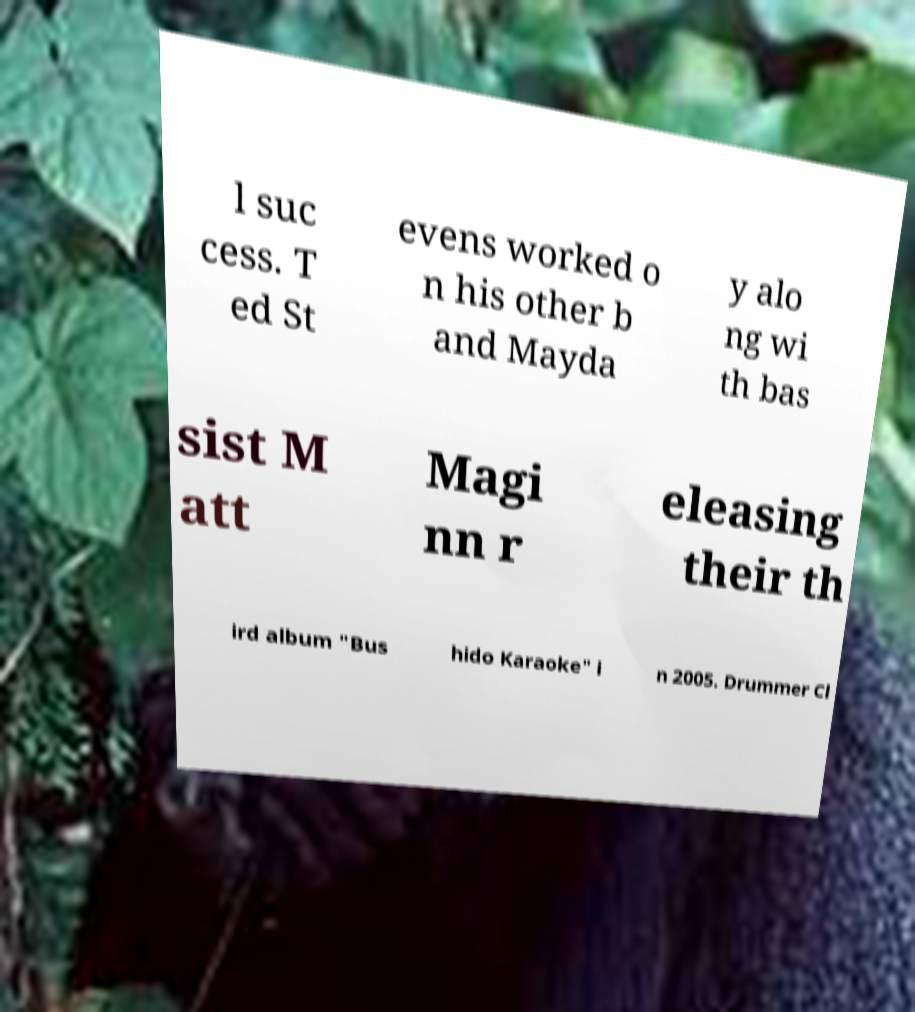Can you accurately transcribe the text from the provided image for me? l suc cess. T ed St evens worked o n his other b and Mayda y alo ng wi th bas sist M att Magi nn r eleasing their th ird album "Bus hido Karaoke" i n 2005. Drummer Cl 